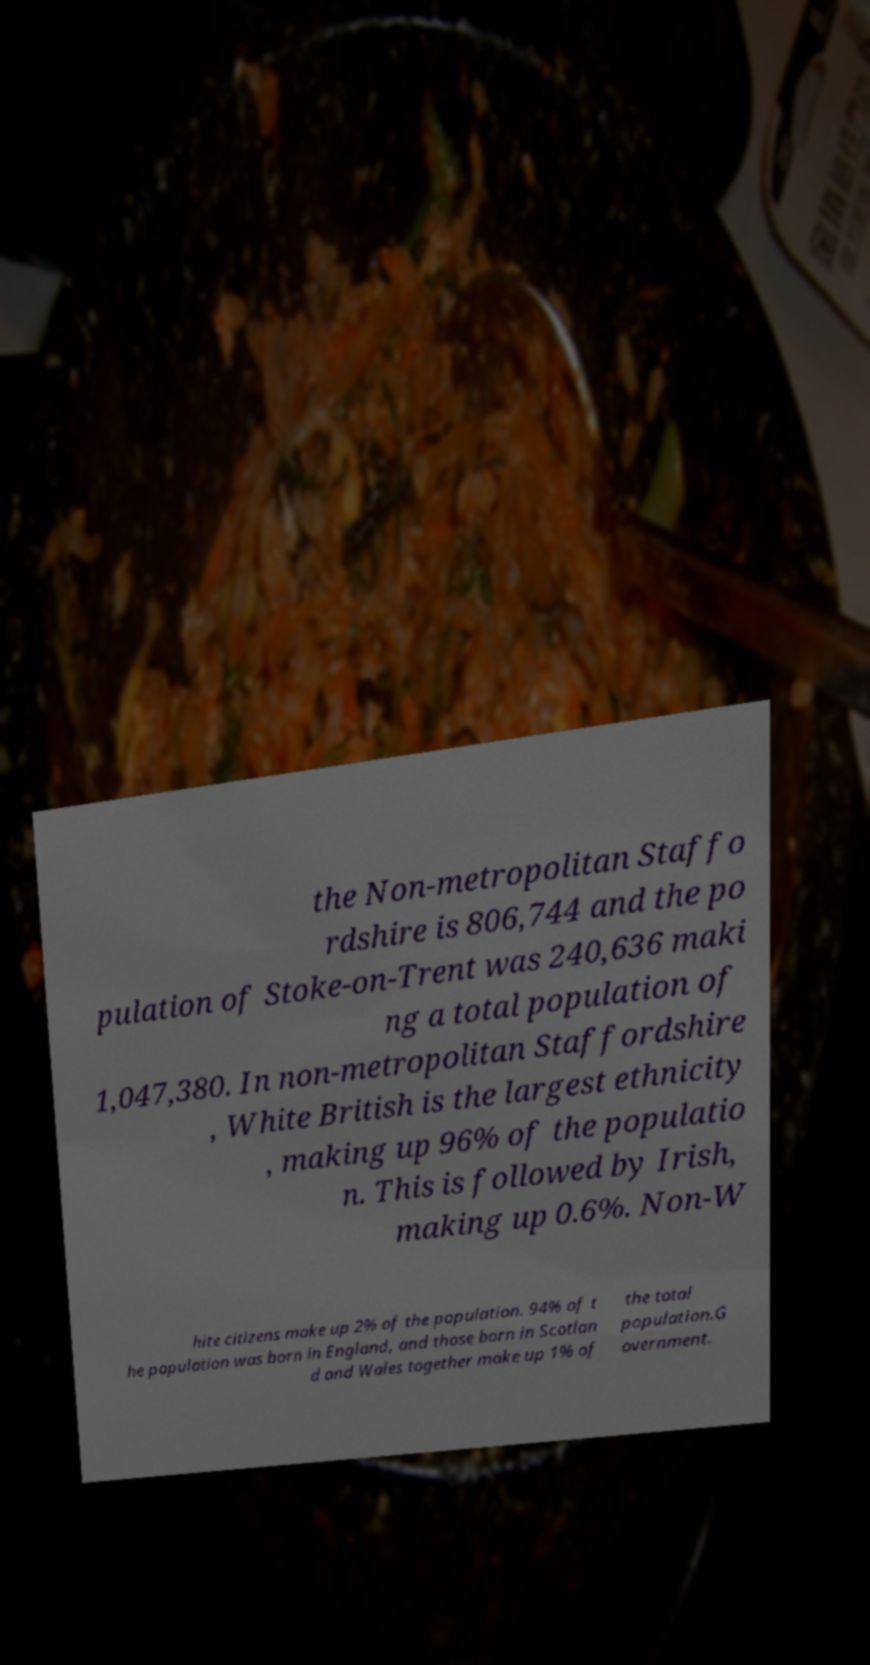Please identify and transcribe the text found in this image. the Non-metropolitan Staffo rdshire is 806,744 and the po pulation of Stoke-on-Trent was 240,636 maki ng a total population of 1,047,380. In non-metropolitan Staffordshire , White British is the largest ethnicity , making up 96% of the populatio n. This is followed by Irish, making up 0.6%. Non-W hite citizens make up 2% of the population. 94% of t he population was born in England, and those born in Scotlan d and Wales together make up 1% of the total population.G overnment. 